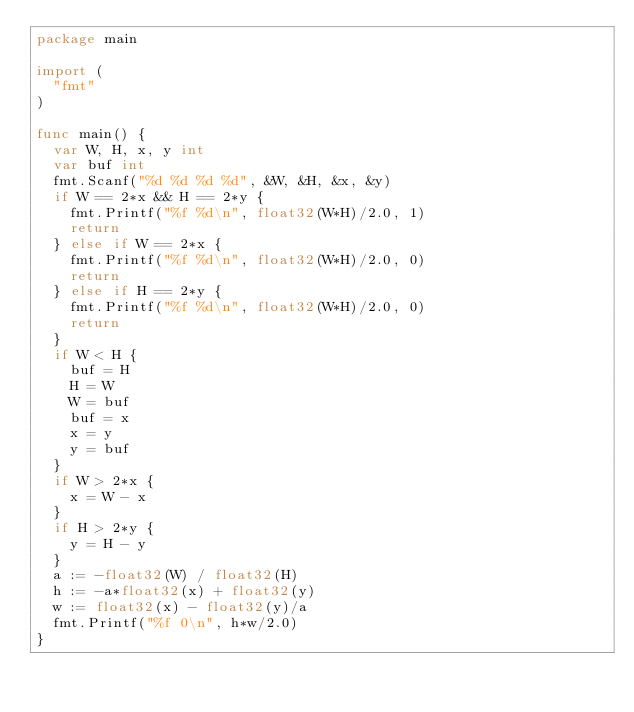<code> <loc_0><loc_0><loc_500><loc_500><_Go_>package main

import (
	"fmt"
)

func main() {
	var W, H, x, y int
	var buf int
	fmt.Scanf("%d %d %d %d", &W, &H, &x, &y)
	if W == 2*x && H == 2*y {
		fmt.Printf("%f %d\n", float32(W*H)/2.0, 1)
		return
	} else if W == 2*x {
		fmt.Printf("%f %d\n", float32(W*H)/2.0, 0)
		return
	} else if H == 2*y {
		fmt.Printf("%f %d\n", float32(W*H)/2.0, 0)
		return
	}
	if W < H {
		buf = H
		H = W
		W = buf
		buf = x
		x = y
		y = buf
	}
	if W > 2*x {
		x = W - x
	}
	if H > 2*y {
		y = H - y
	}
	a := -float32(W) / float32(H)
	h := -a*float32(x) + float32(y)
	w := float32(x) - float32(y)/a
	fmt.Printf("%f 0\n", h*w/2.0)
}
</code> 